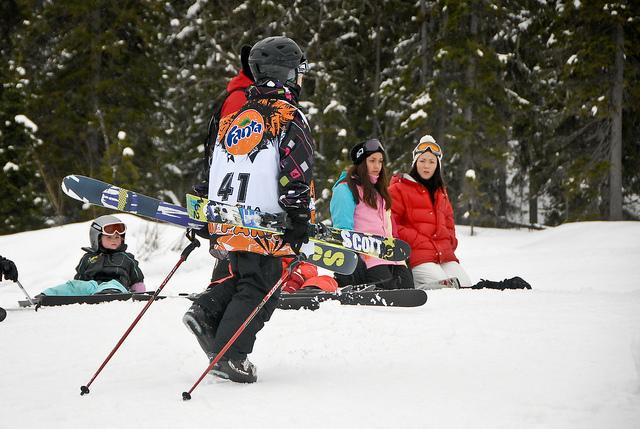What color are the poles dragged around by the young child with his skis? Please explain your reasoning. red. This is obvious by just looking at the poles. 